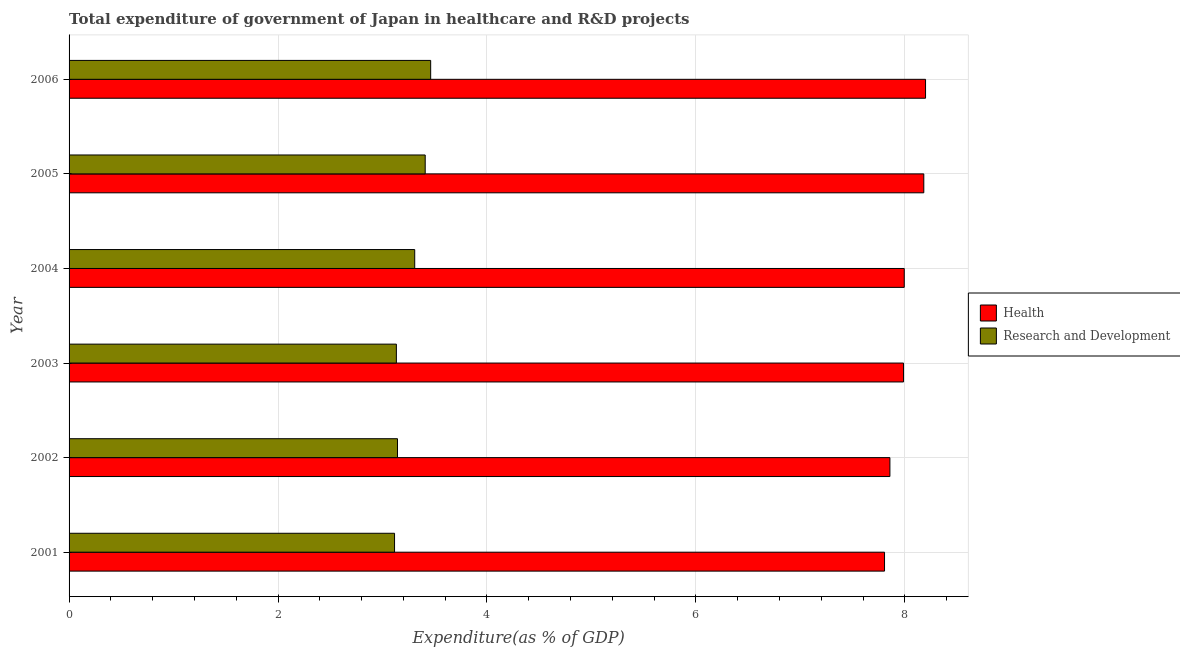How many different coloured bars are there?
Give a very brief answer. 2. Are the number of bars on each tick of the Y-axis equal?
Your response must be concise. Yes. How many bars are there on the 5th tick from the top?
Give a very brief answer. 2. How many bars are there on the 1st tick from the bottom?
Ensure brevity in your answer.  2. What is the label of the 1st group of bars from the top?
Provide a succinct answer. 2006. In how many cases, is the number of bars for a given year not equal to the number of legend labels?
Provide a short and direct response. 0. What is the expenditure in r&d in 2004?
Make the answer very short. 3.31. Across all years, what is the maximum expenditure in r&d?
Offer a very short reply. 3.46. Across all years, what is the minimum expenditure in r&d?
Provide a short and direct response. 3.12. In which year was the expenditure in healthcare maximum?
Your answer should be very brief. 2006. What is the total expenditure in r&d in the graph?
Make the answer very short. 19.57. What is the difference between the expenditure in r&d in 2004 and that in 2005?
Provide a short and direct response. -0.1. What is the difference between the expenditure in healthcare in 2002 and the expenditure in r&d in 2001?
Your answer should be very brief. 4.74. What is the average expenditure in healthcare per year?
Provide a short and direct response. 8. In the year 2001, what is the difference between the expenditure in r&d and expenditure in healthcare?
Make the answer very short. -4.69. What is the difference between the highest and the second highest expenditure in r&d?
Your answer should be very brief. 0.05. What is the difference between the highest and the lowest expenditure in r&d?
Keep it short and to the point. 0.35. What does the 1st bar from the top in 2006 represents?
Offer a very short reply. Research and Development. What does the 2nd bar from the bottom in 2005 represents?
Your answer should be compact. Research and Development. How many bars are there?
Offer a terse response. 12. Are all the bars in the graph horizontal?
Your response must be concise. Yes. How many years are there in the graph?
Give a very brief answer. 6. Are the values on the major ticks of X-axis written in scientific E-notation?
Give a very brief answer. No. Where does the legend appear in the graph?
Keep it short and to the point. Center right. How many legend labels are there?
Make the answer very short. 2. What is the title of the graph?
Your answer should be very brief. Total expenditure of government of Japan in healthcare and R&D projects. Does "Domestic Liabilities" appear as one of the legend labels in the graph?
Provide a succinct answer. No. What is the label or title of the X-axis?
Provide a short and direct response. Expenditure(as % of GDP). What is the Expenditure(as % of GDP) in Health in 2001?
Provide a succinct answer. 7.81. What is the Expenditure(as % of GDP) of Research and Development in 2001?
Your response must be concise. 3.12. What is the Expenditure(as % of GDP) in Health in 2002?
Ensure brevity in your answer.  7.86. What is the Expenditure(as % of GDP) in Research and Development in 2002?
Provide a short and direct response. 3.14. What is the Expenditure(as % of GDP) of Health in 2003?
Provide a short and direct response. 7.99. What is the Expenditure(as % of GDP) in Research and Development in 2003?
Keep it short and to the point. 3.13. What is the Expenditure(as % of GDP) of Health in 2004?
Make the answer very short. 7.99. What is the Expenditure(as % of GDP) of Research and Development in 2004?
Provide a succinct answer. 3.31. What is the Expenditure(as % of GDP) of Health in 2005?
Provide a succinct answer. 8.18. What is the Expenditure(as % of GDP) of Research and Development in 2005?
Make the answer very short. 3.41. What is the Expenditure(as % of GDP) of Health in 2006?
Offer a very short reply. 8.2. What is the Expenditure(as % of GDP) of Research and Development in 2006?
Make the answer very short. 3.46. Across all years, what is the maximum Expenditure(as % of GDP) in Health?
Give a very brief answer. 8.2. Across all years, what is the maximum Expenditure(as % of GDP) of Research and Development?
Ensure brevity in your answer.  3.46. Across all years, what is the minimum Expenditure(as % of GDP) of Health?
Keep it short and to the point. 7.81. Across all years, what is the minimum Expenditure(as % of GDP) of Research and Development?
Ensure brevity in your answer.  3.12. What is the total Expenditure(as % of GDP) in Health in the graph?
Offer a very short reply. 48.03. What is the total Expenditure(as % of GDP) in Research and Development in the graph?
Provide a succinct answer. 19.57. What is the difference between the Expenditure(as % of GDP) in Health in 2001 and that in 2002?
Keep it short and to the point. -0.05. What is the difference between the Expenditure(as % of GDP) in Research and Development in 2001 and that in 2002?
Make the answer very short. -0.03. What is the difference between the Expenditure(as % of GDP) of Health in 2001 and that in 2003?
Your answer should be very brief. -0.18. What is the difference between the Expenditure(as % of GDP) of Research and Development in 2001 and that in 2003?
Your response must be concise. -0.02. What is the difference between the Expenditure(as % of GDP) of Health in 2001 and that in 2004?
Offer a terse response. -0.19. What is the difference between the Expenditure(as % of GDP) in Research and Development in 2001 and that in 2004?
Your answer should be very brief. -0.19. What is the difference between the Expenditure(as % of GDP) in Health in 2001 and that in 2005?
Provide a succinct answer. -0.38. What is the difference between the Expenditure(as % of GDP) in Research and Development in 2001 and that in 2005?
Your answer should be very brief. -0.29. What is the difference between the Expenditure(as % of GDP) of Health in 2001 and that in 2006?
Your response must be concise. -0.39. What is the difference between the Expenditure(as % of GDP) in Research and Development in 2001 and that in 2006?
Offer a very short reply. -0.35. What is the difference between the Expenditure(as % of GDP) of Health in 2002 and that in 2003?
Give a very brief answer. -0.13. What is the difference between the Expenditure(as % of GDP) of Research and Development in 2002 and that in 2003?
Provide a succinct answer. 0.01. What is the difference between the Expenditure(as % of GDP) of Health in 2002 and that in 2004?
Ensure brevity in your answer.  -0.14. What is the difference between the Expenditure(as % of GDP) in Research and Development in 2002 and that in 2004?
Offer a very short reply. -0.16. What is the difference between the Expenditure(as % of GDP) in Health in 2002 and that in 2005?
Provide a short and direct response. -0.32. What is the difference between the Expenditure(as % of GDP) of Research and Development in 2002 and that in 2005?
Provide a short and direct response. -0.27. What is the difference between the Expenditure(as % of GDP) in Health in 2002 and that in 2006?
Keep it short and to the point. -0.34. What is the difference between the Expenditure(as % of GDP) in Research and Development in 2002 and that in 2006?
Provide a short and direct response. -0.32. What is the difference between the Expenditure(as % of GDP) of Health in 2003 and that in 2004?
Your answer should be compact. -0.01. What is the difference between the Expenditure(as % of GDP) in Research and Development in 2003 and that in 2004?
Your answer should be compact. -0.18. What is the difference between the Expenditure(as % of GDP) of Health in 2003 and that in 2005?
Your answer should be compact. -0.19. What is the difference between the Expenditure(as % of GDP) in Research and Development in 2003 and that in 2005?
Provide a short and direct response. -0.28. What is the difference between the Expenditure(as % of GDP) of Health in 2003 and that in 2006?
Provide a short and direct response. -0.21. What is the difference between the Expenditure(as % of GDP) of Research and Development in 2003 and that in 2006?
Offer a very short reply. -0.33. What is the difference between the Expenditure(as % of GDP) of Health in 2004 and that in 2005?
Provide a succinct answer. -0.19. What is the difference between the Expenditure(as % of GDP) of Research and Development in 2004 and that in 2005?
Your answer should be compact. -0.1. What is the difference between the Expenditure(as % of GDP) in Health in 2004 and that in 2006?
Make the answer very short. -0.2. What is the difference between the Expenditure(as % of GDP) in Research and Development in 2004 and that in 2006?
Provide a succinct answer. -0.15. What is the difference between the Expenditure(as % of GDP) of Health in 2005 and that in 2006?
Ensure brevity in your answer.  -0.02. What is the difference between the Expenditure(as % of GDP) of Research and Development in 2005 and that in 2006?
Your answer should be compact. -0.05. What is the difference between the Expenditure(as % of GDP) of Health in 2001 and the Expenditure(as % of GDP) of Research and Development in 2002?
Your response must be concise. 4.66. What is the difference between the Expenditure(as % of GDP) in Health in 2001 and the Expenditure(as % of GDP) in Research and Development in 2003?
Your response must be concise. 4.67. What is the difference between the Expenditure(as % of GDP) in Health in 2001 and the Expenditure(as % of GDP) in Research and Development in 2004?
Ensure brevity in your answer.  4.5. What is the difference between the Expenditure(as % of GDP) in Health in 2001 and the Expenditure(as % of GDP) in Research and Development in 2005?
Your answer should be compact. 4.4. What is the difference between the Expenditure(as % of GDP) in Health in 2001 and the Expenditure(as % of GDP) in Research and Development in 2006?
Provide a short and direct response. 4.34. What is the difference between the Expenditure(as % of GDP) of Health in 2002 and the Expenditure(as % of GDP) of Research and Development in 2003?
Your answer should be very brief. 4.72. What is the difference between the Expenditure(as % of GDP) of Health in 2002 and the Expenditure(as % of GDP) of Research and Development in 2004?
Offer a very short reply. 4.55. What is the difference between the Expenditure(as % of GDP) in Health in 2002 and the Expenditure(as % of GDP) in Research and Development in 2005?
Your response must be concise. 4.45. What is the difference between the Expenditure(as % of GDP) of Health in 2002 and the Expenditure(as % of GDP) of Research and Development in 2006?
Give a very brief answer. 4.4. What is the difference between the Expenditure(as % of GDP) in Health in 2003 and the Expenditure(as % of GDP) in Research and Development in 2004?
Offer a terse response. 4.68. What is the difference between the Expenditure(as % of GDP) in Health in 2003 and the Expenditure(as % of GDP) in Research and Development in 2005?
Give a very brief answer. 4.58. What is the difference between the Expenditure(as % of GDP) of Health in 2003 and the Expenditure(as % of GDP) of Research and Development in 2006?
Give a very brief answer. 4.53. What is the difference between the Expenditure(as % of GDP) of Health in 2004 and the Expenditure(as % of GDP) of Research and Development in 2005?
Make the answer very short. 4.59. What is the difference between the Expenditure(as % of GDP) of Health in 2004 and the Expenditure(as % of GDP) of Research and Development in 2006?
Your response must be concise. 4.53. What is the difference between the Expenditure(as % of GDP) in Health in 2005 and the Expenditure(as % of GDP) in Research and Development in 2006?
Your answer should be compact. 4.72. What is the average Expenditure(as % of GDP) in Health per year?
Make the answer very short. 8. What is the average Expenditure(as % of GDP) in Research and Development per year?
Your response must be concise. 3.26. In the year 2001, what is the difference between the Expenditure(as % of GDP) of Health and Expenditure(as % of GDP) of Research and Development?
Provide a short and direct response. 4.69. In the year 2002, what is the difference between the Expenditure(as % of GDP) in Health and Expenditure(as % of GDP) in Research and Development?
Provide a short and direct response. 4.71. In the year 2003, what is the difference between the Expenditure(as % of GDP) of Health and Expenditure(as % of GDP) of Research and Development?
Your answer should be very brief. 4.85. In the year 2004, what is the difference between the Expenditure(as % of GDP) in Health and Expenditure(as % of GDP) in Research and Development?
Keep it short and to the point. 4.69. In the year 2005, what is the difference between the Expenditure(as % of GDP) in Health and Expenditure(as % of GDP) in Research and Development?
Make the answer very short. 4.77. In the year 2006, what is the difference between the Expenditure(as % of GDP) in Health and Expenditure(as % of GDP) in Research and Development?
Offer a terse response. 4.74. What is the ratio of the Expenditure(as % of GDP) of Health in 2001 to that in 2002?
Your response must be concise. 0.99. What is the ratio of the Expenditure(as % of GDP) of Health in 2001 to that in 2003?
Offer a terse response. 0.98. What is the ratio of the Expenditure(as % of GDP) in Health in 2001 to that in 2004?
Your answer should be compact. 0.98. What is the ratio of the Expenditure(as % of GDP) in Research and Development in 2001 to that in 2004?
Make the answer very short. 0.94. What is the ratio of the Expenditure(as % of GDP) of Health in 2001 to that in 2005?
Your response must be concise. 0.95. What is the ratio of the Expenditure(as % of GDP) in Research and Development in 2001 to that in 2005?
Offer a very short reply. 0.91. What is the ratio of the Expenditure(as % of GDP) in Health in 2001 to that in 2006?
Your answer should be compact. 0.95. What is the ratio of the Expenditure(as % of GDP) of Research and Development in 2001 to that in 2006?
Your response must be concise. 0.9. What is the ratio of the Expenditure(as % of GDP) of Health in 2002 to that in 2003?
Provide a succinct answer. 0.98. What is the ratio of the Expenditure(as % of GDP) of Health in 2002 to that in 2004?
Give a very brief answer. 0.98. What is the ratio of the Expenditure(as % of GDP) in Research and Development in 2002 to that in 2004?
Provide a short and direct response. 0.95. What is the ratio of the Expenditure(as % of GDP) of Health in 2002 to that in 2005?
Give a very brief answer. 0.96. What is the ratio of the Expenditure(as % of GDP) in Research and Development in 2002 to that in 2005?
Provide a short and direct response. 0.92. What is the ratio of the Expenditure(as % of GDP) in Health in 2002 to that in 2006?
Offer a very short reply. 0.96. What is the ratio of the Expenditure(as % of GDP) in Research and Development in 2002 to that in 2006?
Give a very brief answer. 0.91. What is the ratio of the Expenditure(as % of GDP) of Health in 2003 to that in 2004?
Your response must be concise. 1. What is the ratio of the Expenditure(as % of GDP) of Research and Development in 2003 to that in 2004?
Your response must be concise. 0.95. What is the ratio of the Expenditure(as % of GDP) in Health in 2003 to that in 2005?
Offer a very short reply. 0.98. What is the ratio of the Expenditure(as % of GDP) in Research and Development in 2003 to that in 2005?
Offer a terse response. 0.92. What is the ratio of the Expenditure(as % of GDP) in Health in 2003 to that in 2006?
Make the answer very short. 0.97. What is the ratio of the Expenditure(as % of GDP) of Research and Development in 2003 to that in 2006?
Offer a very short reply. 0.91. What is the ratio of the Expenditure(as % of GDP) in Health in 2004 to that in 2005?
Ensure brevity in your answer.  0.98. What is the ratio of the Expenditure(as % of GDP) of Research and Development in 2004 to that in 2005?
Offer a very short reply. 0.97. What is the ratio of the Expenditure(as % of GDP) in Health in 2004 to that in 2006?
Offer a terse response. 0.98. What is the ratio of the Expenditure(as % of GDP) of Research and Development in 2004 to that in 2006?
Provide a succinct answer. 0.96. What is the ratio of the Expenditure(as % of GDP) in Health in 2005 to that in 2006?
Give a very brief answer. 1. What is the ratio of the Expenditure(as % of GDP) of Research and Development in 2005 to that in 2006?
Provide a succinct answer. 0.98. What is the difference between the highest and the second highest Expenditure(as % of GDP) of Health?
Provide a succinct answer. 0.02. What is the difference between the highest and the second highest Expenditure(as % of GDP) in Research and Development?
Keep it short and to the point. 0.05. What is the difference between the highest and the lowest Expenditure(as % of GDP) of Health?
Offer a very short reply. 0.39. What is the difference between the highest and the lowest Expenditure(as % of GDP) in Research and Development?
Provide a succinct answer. 0.35. 